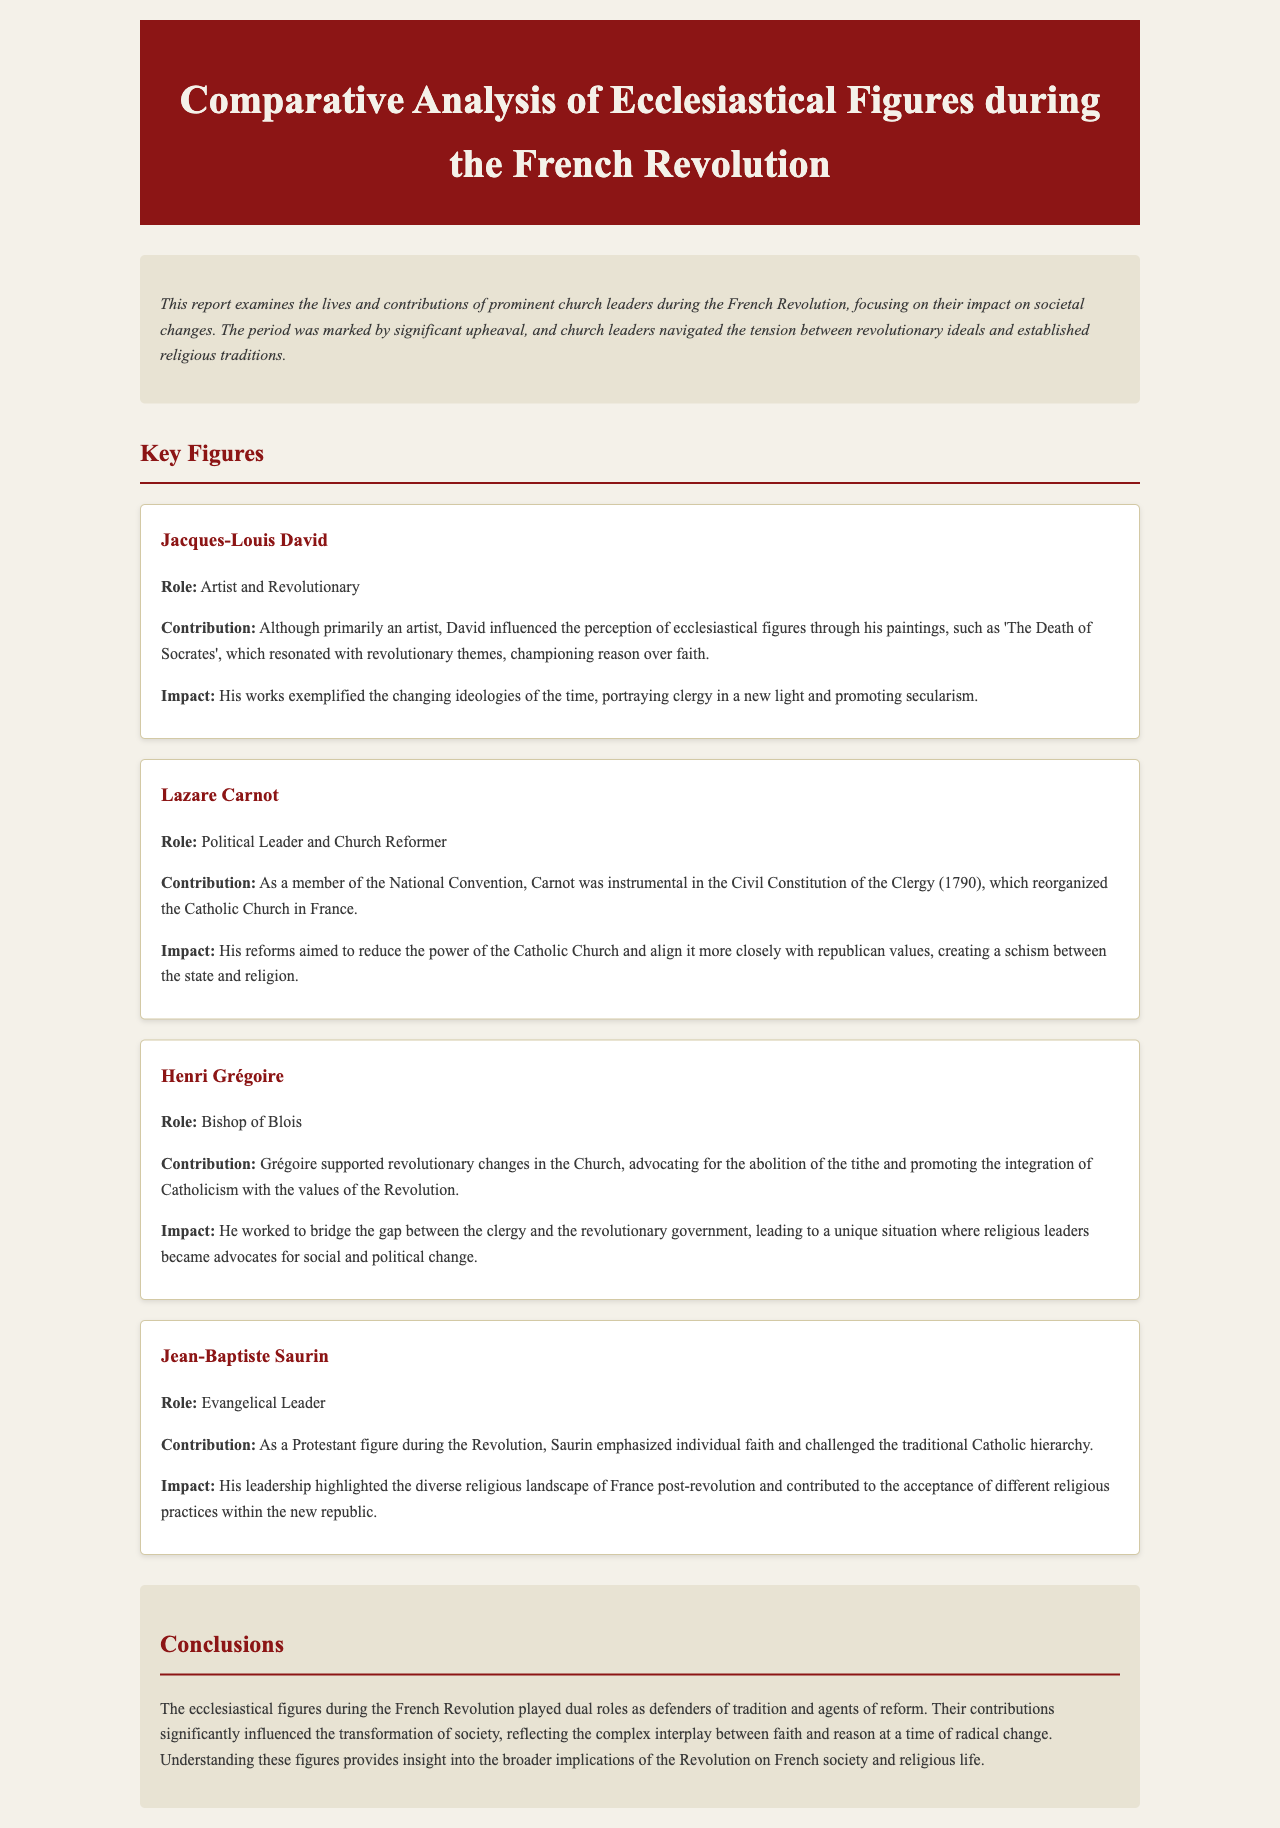What is the title of the report? The title of the report is stated in the header section of the document.
Answer: Comparative Analysis of Ecclesiastical Figures during the French Revolution Who was the Bishop of Blois? The document identifies the Bishop of Blois among the key figures discussed.
Answer: Henri Grégoire What key political event did Lazare Carnot influence? The contribution of Lazare Carnot is linked to a specific political reform in the document.
Answer: Civil Constitution of the Clergy Which artist's works exemplified changing ideologies? The document mentions an artist whose works reflected revolutionary themes.
Answer: Jacques-Louis David What was Jean-Baptiste Saurin's role during the Revolution? The document classifies Jean-Baptiste Saurin's role among the key figures in this context.
Answer: Evangelical Leader What was Henri Grégoire's contribution regarding the tithe? The document specifies Henri Grégoire's stance on a particular issue affecting the Church.
Answer: Abolition How did Lazare Carnot's reforms affect the Catholic Church? The impact of Carnot's reforms is explained in relation to the church's power dynamics.
Answer: Reduced power What type of changes did ecclesiastical figures support? The document discusses various societal transformations supported by church leaders.
Answer: Revolutionary changes What color is the background of the document? The document provides a description of the overall visual style, including background color.
Answer: Light beige 